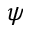Convert formula to latex. <formula><loc_0><loc_0><loc_500><loc_500>\psi</formula> 